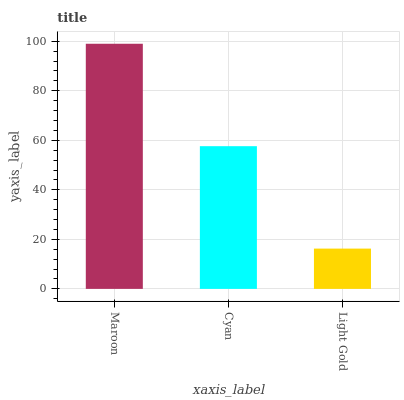Is Cyan the minimum?
Answer yes or no. No. Is Cyan the maximum?
Answer yes or no. No. Is Maroon greater than Cyan?
Answer yes or no. Yes. Is Cyan less than Maroon?
Answer yes or no. Yes. Is Cyan greater than Maroon?
Answer yes or no. No. Is Maroon less than Cyan?
Answer yes or no. No. Is Cyan the high median?
Answer yes or no. Yes. Is Cyan the low median?
Answer yes or no. Yes. Is Light Gold the high median?
Answer yes or no. No. Is Light Gold the low median?
Answer yes or no. No. 